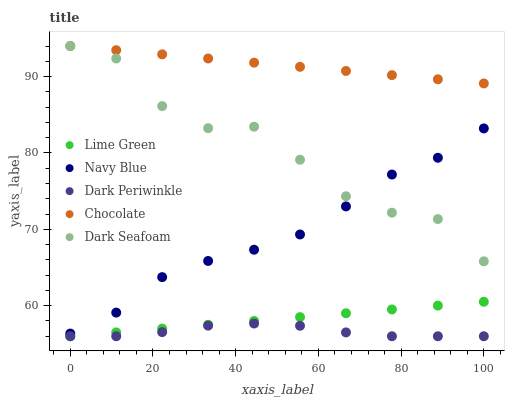Does Dark Periwinkle have the minimum area under the curve?
Answer yes or no. Yes. Does Chocolate have the maximum area under the curve?
Answer yes or no. Yes. Does Dark Seafoam have the minimum area under the curve?
Answer yes or no. No. Does Dark Seafoam have the maximum area under the curve?
Answer yes or no. No. Is Chocolate the smoothest?
Answer yes or no. Yes. Is Dark Seafoam the roughest?
Answer yes or no. Yes. Is Lime Green the smoothest?
Answer yes or no. No. Is Lime Green the roughest?
Answer yes or no. No. Does Lime Green have the lowest value?
Answer yes or no. Yes. Does Dark Seafoam have the lowest value?
Answer yes or no. No. Does Chocolate have the highest value?
Answer yes or no. Yes. Does Lime Green have the highest value?
Answer yes or no. No. Is Dark Periwinkle less than Chocolate?
Answer yes or no. Yes. Is Chocolate greater than Navy Blue?
Answer yes or no. Yes. Does Dark Seafoam intersect Navy Blue?
Answer yes or no. Yes. Is Dark Seafoam less than Navy Blue?
Answer yes or no. No. Is Dark Seafoam greater than Navy Blue?
Answer yes or no. No. Does Dark Periwinkle intersect Chocolate?
Answer yes or no. No. 